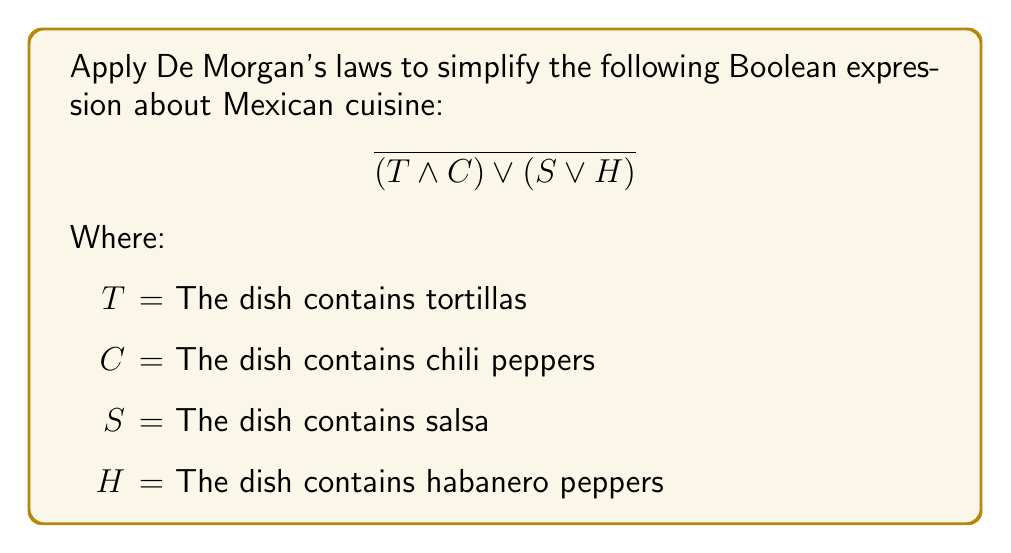Could you help me with this problem? Let's apply De Morgan's laws step-by-step to simplify this expression:

1) First, we apply De Morgan's law to the entire expression:
   $$\overline{(T \land C) \lor (S \lor H)} = \overline{(T \land C)} \land \overline{(S \lor H)}$$

2) Now, we apply De Morgan's law to each part separately:

   For $\overline{(T \land C)}$:
   $$\overline{(T \land C)} = \overline{T} \lor \overline{C}$$

   For $\overline{(S \lor H)}$:
   $$\overline{(S \lor H)} = \overline{S} \land \overline{H}$$

3) Substituting these back into our expression:
   $$(\overline{T} \lor \overline{C}) \land (\overline{S} \land \overline{H})$$

4) This can be interpreted as: "The dish does not contain tortillas or does not contain chili peppers, AND it does not contain salsa and does not contain habanero peppers."

This simplified expression represents dishes that lack some of the key ingredients in traditional Mexican cuisine, showcasing the diversity and complexity of Mexican culinary traditions.
Answer: $$(\overline{T} \lor \overline{C}) \land (\overline{S} \land \overline{H})$$ 